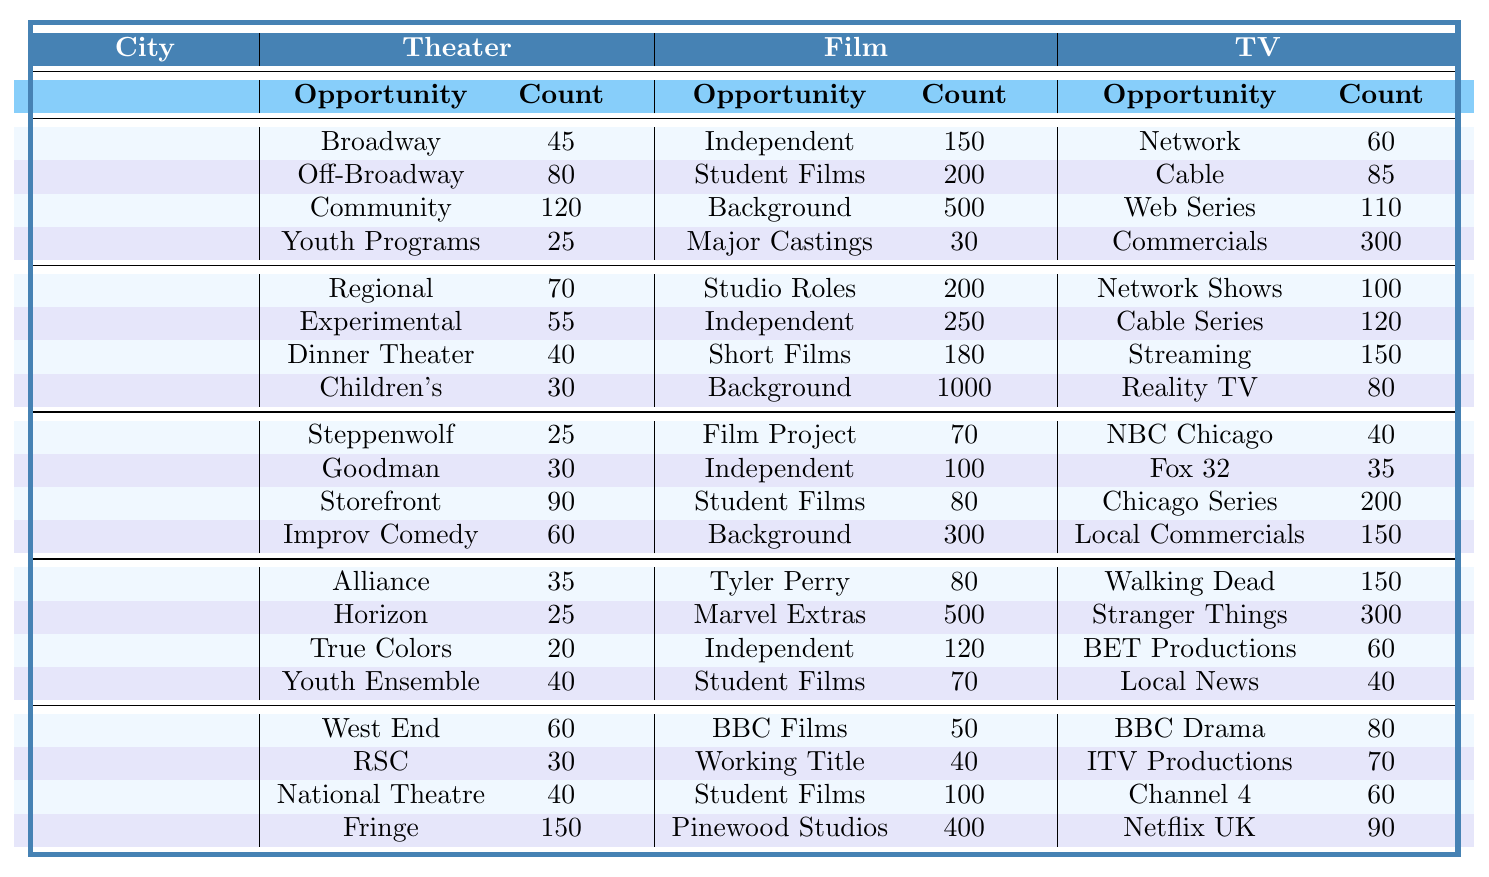What city has the highest number of Independent Film Roles? According to the table, Los Angeles has the highest number with 200 Independent Film Roles, while other cities have fewer.
Answer: Los Angeles How many background work opportunities are available in New York City? In New York City, there are 500 opportunities for background work listed in the Film category.
Answer: 500 Which city offers the most options for Community Theater Roles? The table shows that New York City has 120 Community Theater Roles, which is the highest among all listed cities.
Answer: New York City What is the total number of theater opportunities in Chicago? To find the total, sum the counts: 25 (Steppenwolf) + 30 (Goodman) + 90 (Storefront) + 60 (Improv) = 205.
Answer: 205 In which category does Atlanta have the highest available roles? In the TV category, Atlanta has 150 roles in The Walking Dead Universe, which is the highest compared to other categories in the same city.
Answer: TV Is the total number of Hollywood Studio Roles in Los Angeles greater than the combined number of roles in Community Theater and Youth Programs in New York City? Los Angeles has 200 Hollywood Studio Roles. New York has 120 Community Theater Roles and 25 in Youth Programs (120 + 25 = 145), which means Hollywood Studio Roles are greater.
Answer: Yes What is the difference in the number of Network TV roles between New York City and Chicago? New York City has 60 Network TV roles, while Chicago has 40. The difference is 60 - 40 = 20.
Answer: 20 Which city has the lowest number of opportunities for Youth Theater Programs? The lowest number for Youth Theater Programs is in New York City with 25 opportunities, compared to other cities that do not offer it.
Answer: New York City Calculate the average number of opportunities available in the Film category for all cities listed. The numbers are: 150, 200, 70, 80, 50, 200 (New York, Los Angeles, Chicago, Atlanta, London). The average is (150 + 200 + 70 + 80 + 50 + 200) / 6 = 138.33.
Answer: 138.33 Does London have more National Theatre Opportunities than Chicago has Storefront Theater Productions? London has 40 National Theatre Opportunities, while Chicago has 90 Storefront Theater Productions, which is greater.
Answer: No 